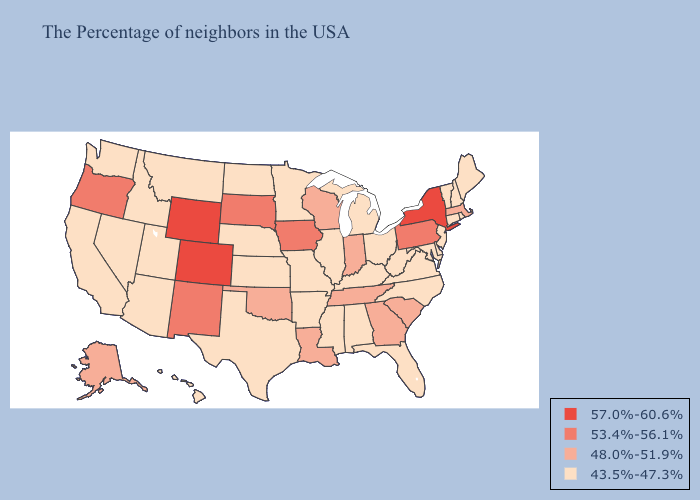Does Maine have a lower value than Arkansas?
Quick response, please. No. Does Vermont have the highest value in the Northeast?
Be succinct. No. What is the lowest value in the South?
Give a very brief answer. 43.5%-47.3%. Does Maryland have a lower value than Colorado?
Quick response, please. Yes. Name the states that have a value in the range 48.0%-51.9%?
Concise answer only. Massachusetts, South Carolina, Georgia, Indiana, Tennessee, Wisconsin, Louisiana, Oklahoma, Alaska. Does Illinois have the highest value in the MidWest?
Answer briefly. No. Does Alaska have the highest value in the USA?
Answer briefly. No. What is the value of Iowa?
Short answer required. 53.4%-56.1%. Does the map have missing data?
Write a very short answer. No. Name the states that have a value in the range 53.4%-56.1%?
Short answer required. Pennsylvania, Iowa, South Dakota, New Mexico, Oregon. What is the value of North Dakota?
Be succinct. 43.5%-47.3%. What is the highest value in the South ?
Be succinct. 48.0%-51.9%. Does Washington have the same value as Ohio?
Give a very brief answer. Yes. Name the states that have a value in the range 57.0%-60.6%?
Keep it brief. New York, Wyoming, Colorado. What is the value of Georgia?
Write a very short answer. 48.0%-51.9%. 